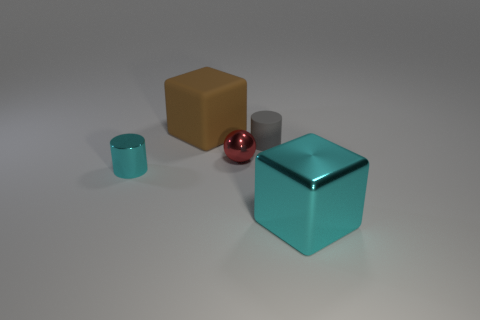Subtract all cyan blocks. How many blocks are left? 1 Add 3 brown matte blocks. How many objects exist? 8 Subtract all blocks. How many objects are left? 3 Subtract 1 spheres. How many spheres are left? 0 Subtract all cyan cylinders. Subtract all blue blocks. How many cylinders are left? 1 Subtract all small objects. Subtract all rubber cubes. How many objects are left? 1 Add 4 tiny shiny balls. How many tiny shiny balls are left? 5 Add 1 cylinders. How many cylinders exist? 3 Subtract 0 red cylinders. How many objects are left? 5 